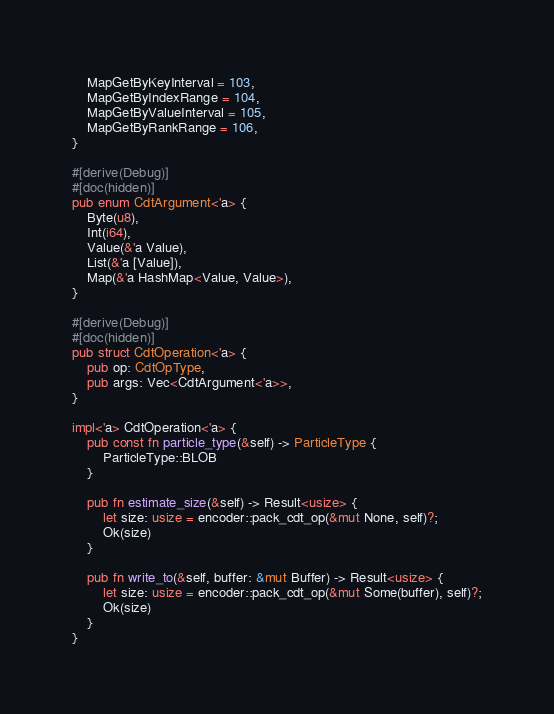<code> <loc_0><loc_0><loc_500><loc_500><_Rust_>    MapGetByKeyInterval = 103,
    MapGetByIndexRange = 104,
    MapGetByValueInterval = 105,
    MapGetByRankRange = 106,
}

#[derive(Debug)]
#[doc(hidden)]
pub enum CdtArgument<'a> {
    Byte(u8),
    Int(i64),
    Value(&'a Value),
    List(&'a [Value]),
    Map(&'a HashMap<Value, Value>),
}

#[derive(Debug)]
#[doc(hidden)]
pub struct CdtOperation<'a> {
    pub op: CdtOpType,
    pub args: Vec<CdtArgument<'a>>,
}

impl<'a> CdtOperation<'a> {
    pub const fn particle_type(&self) -> ParticleType {
        ParticleType::BLOB
    }

    pub fn estimate_size(&self) -> Result<usize> {
        let size: usize = encoder::pack_cdt_op(&mut None, self)?;
        Ok(size)
    }

    pub fn write_to(&self, buffer: &mut Buffer) -> Result<usize> {
        let size: usize = encoder::pack_cdt_op(&mut Some(buffer), self)?;
        Ok(size)
    }
}
</code> 